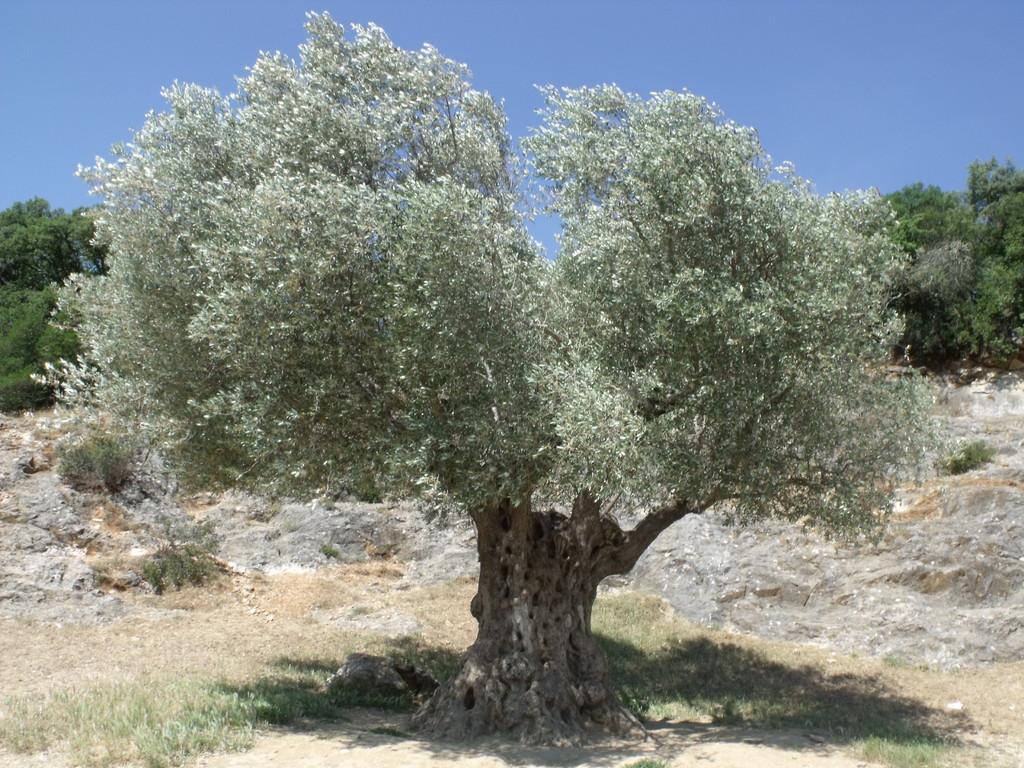Describe this image in one or two sentences. In this image we can see a group of trees. We can also see some grass and the sky. 